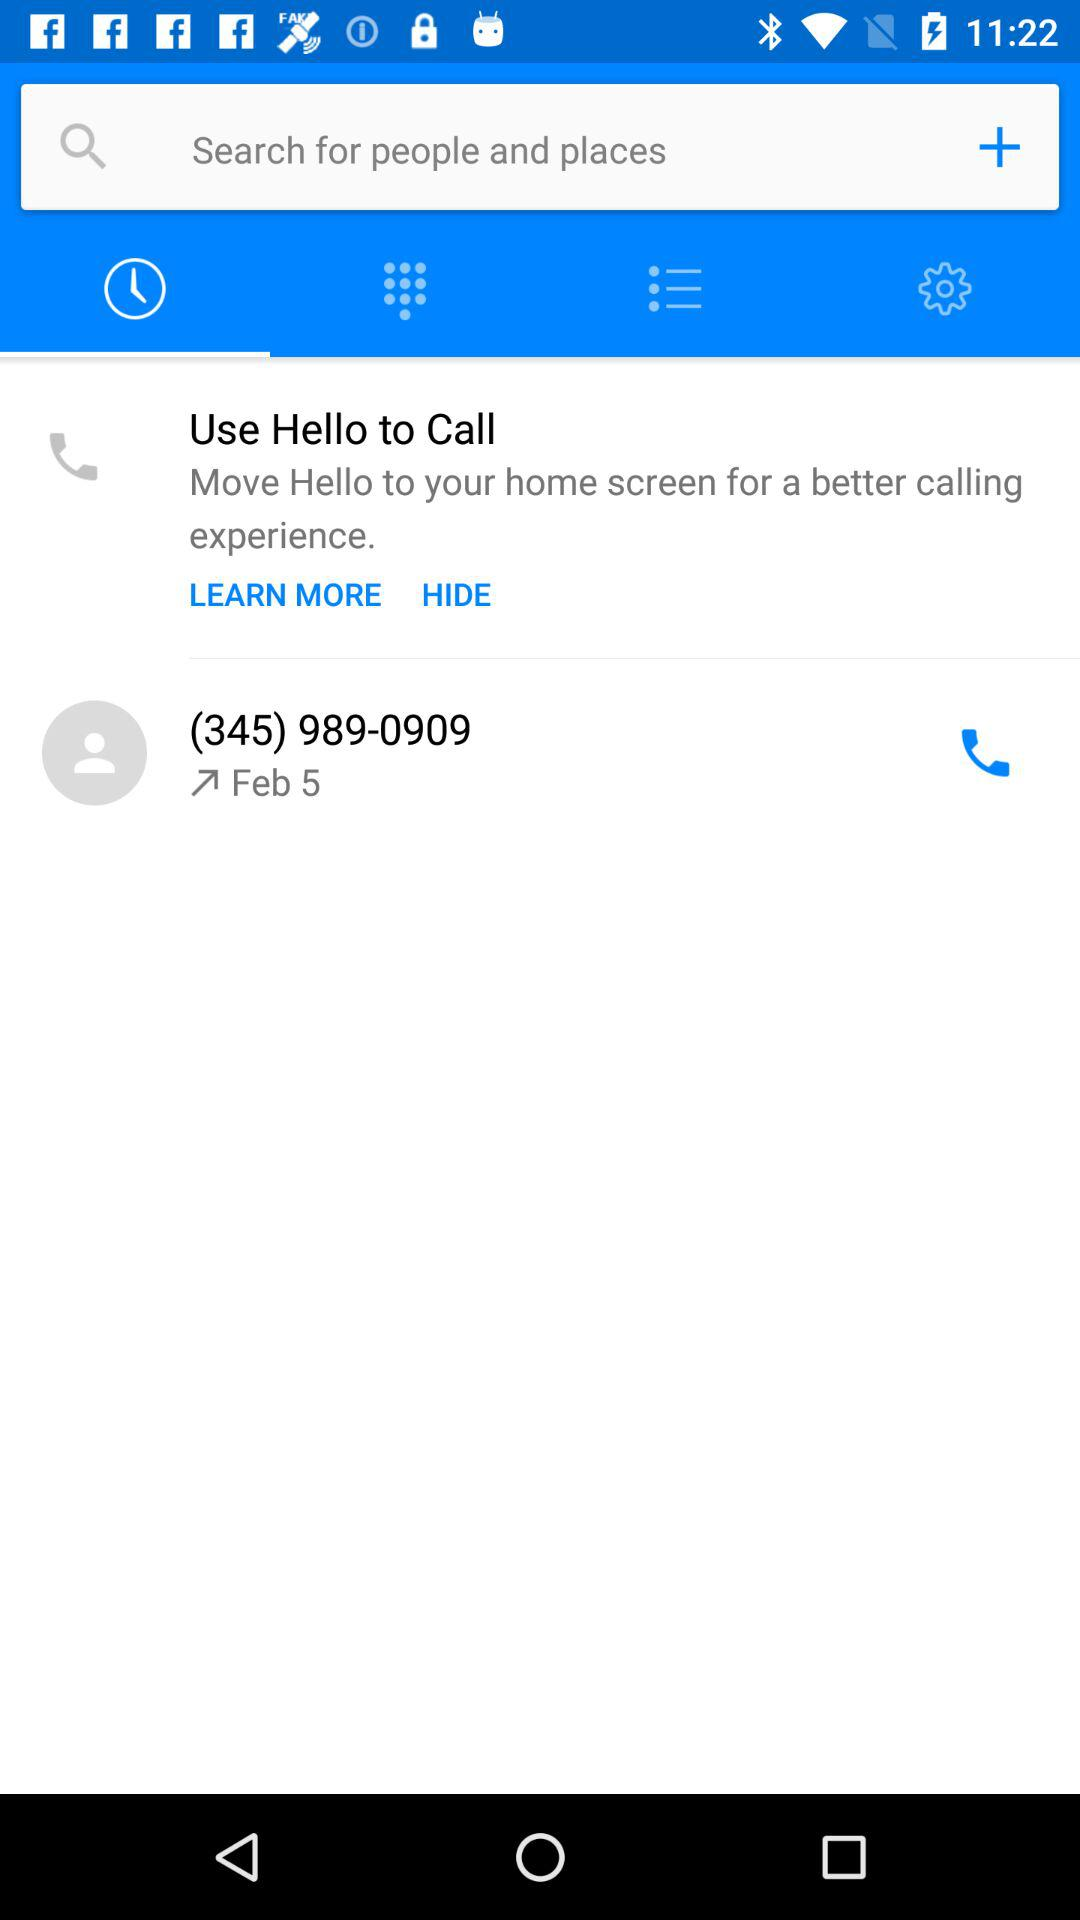Which tab is selected? The selected tab is "Recents". 